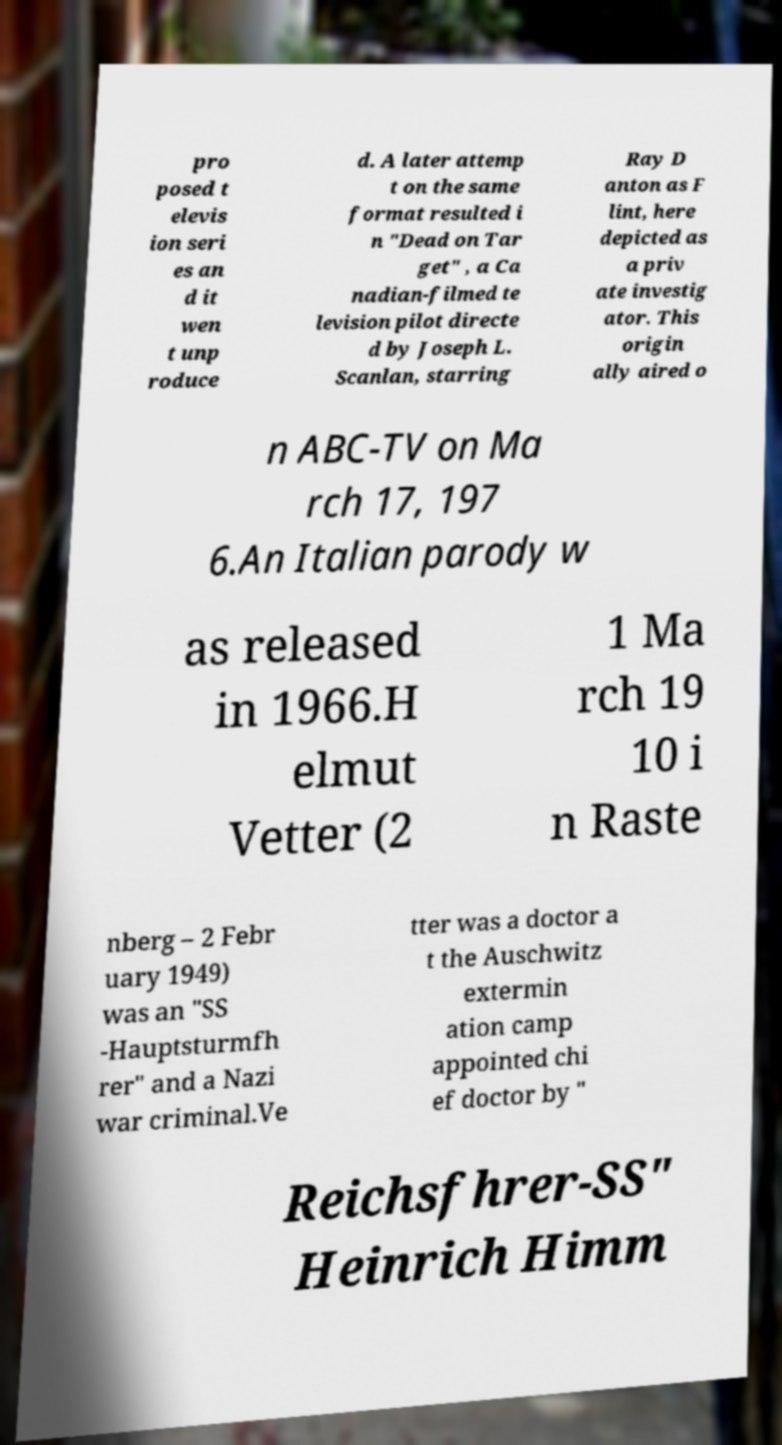For documentation purposes, I need the text within this image transcribed. Could you provide that? pro posed t elevis ion seri es an d it wen t unp roduce d. A later attemp t on the same format resulted i n "Dead on Tar get" , a Ca nadian-filmed te levision pilot directe d by Joseph L. Scanlan, starring Ray D anton as F lint, here depicted as a priv ate investig ator. This origin ally aired o n ABC-TV on Ma rch 17, 197 6.An Italian parody w as released in 1966.H elmut Vetter (2 1 Ma rch 19 10 i n Raste nberg – 2 Febr uary 1949) was an "SS -Hauptsturmfh rer" and a Nazi war criminal.Ve tter was a doctor a t the Auschwitz extermin ation camp appointed chi ef doctor by " Reichsfhrer-SS" Heinrich Himm 